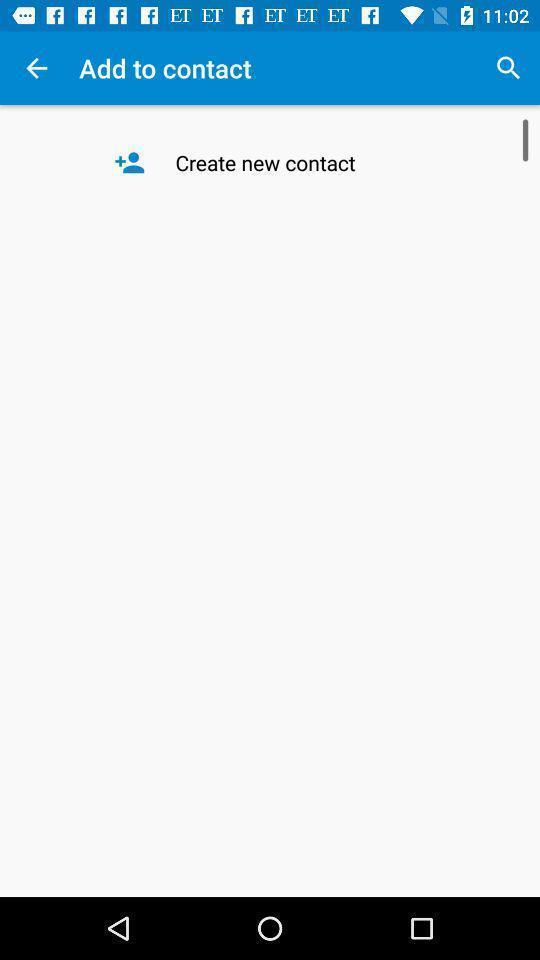Provide a detailed account of this screenshot. Page of add to contacts with create new contact option. 